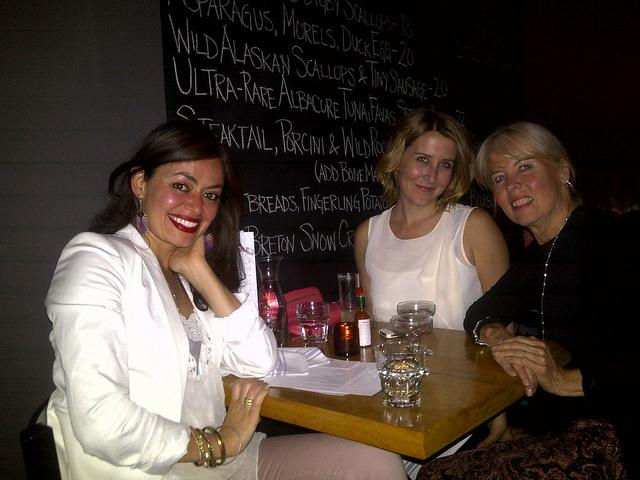What is this place?

Choices:
A) seafood restaurant
B) photographer's studio
C) kitchen
D) bar seafood restaurant 